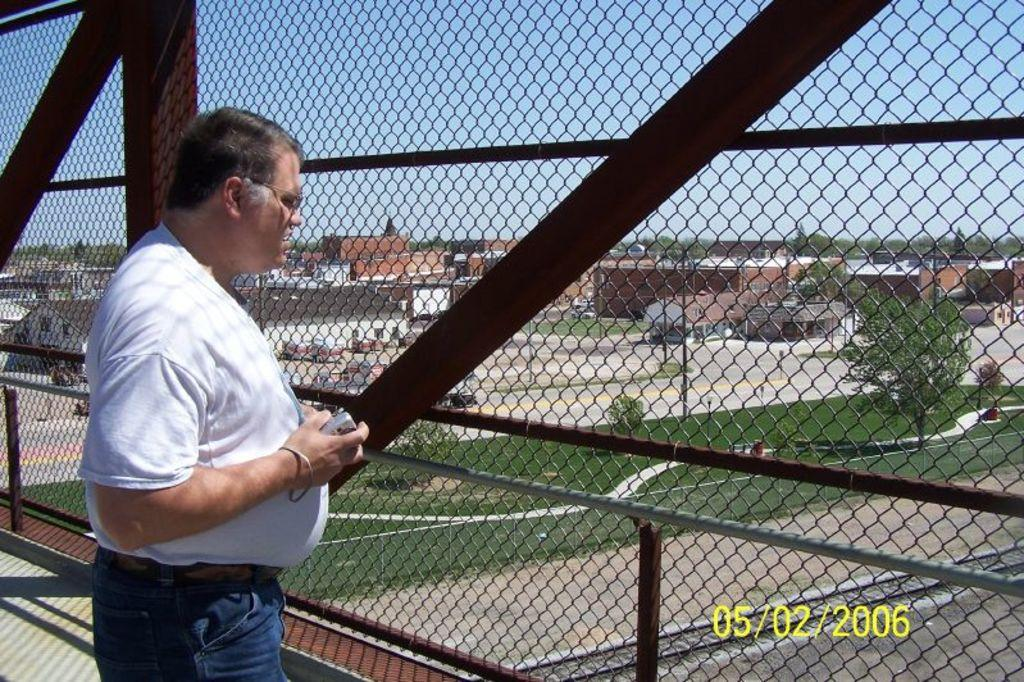What is the man in the image doing? The man is standing in the image. What is the man holding in the image? The man is holding an object. What can be seen in the background of the image? There is a metal fence, grass, trees, buildings, and the sky visible in the background of the image. What type of wool is the actor wearing at the airport in the image? There is no actor or airport present in the image, and no wool can be seen. 